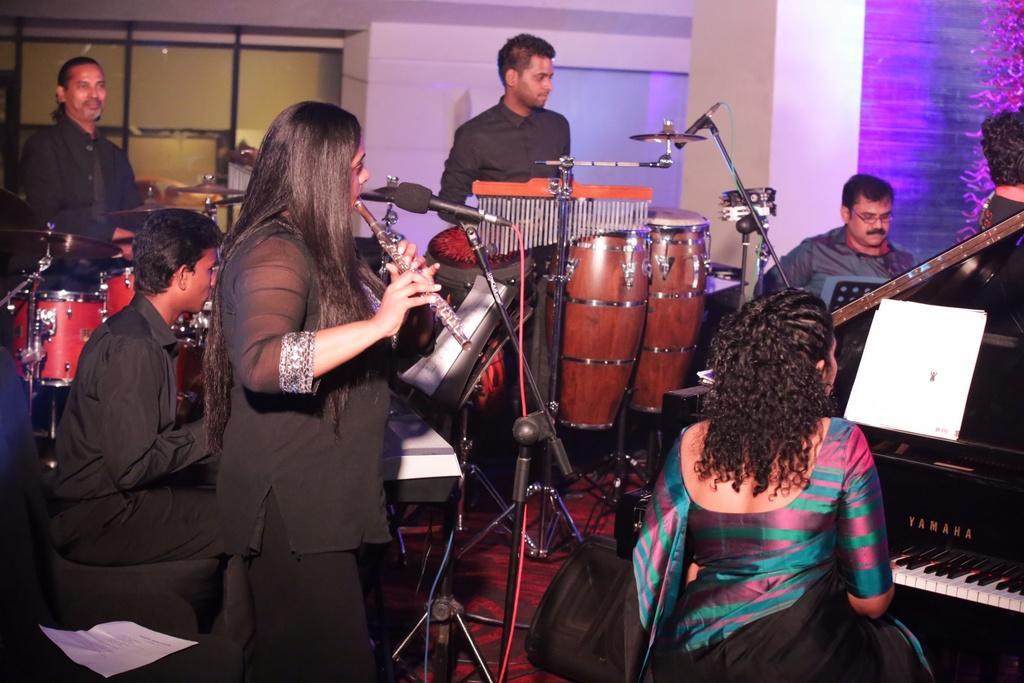Could you give a brief overview of what you see in this image? There is a music band in this room and some musical instruments in everyone's hand. Some of them are sitting in front of a musical instrument. Everyone is playing their respective instruments. In the background there is a wall here. 